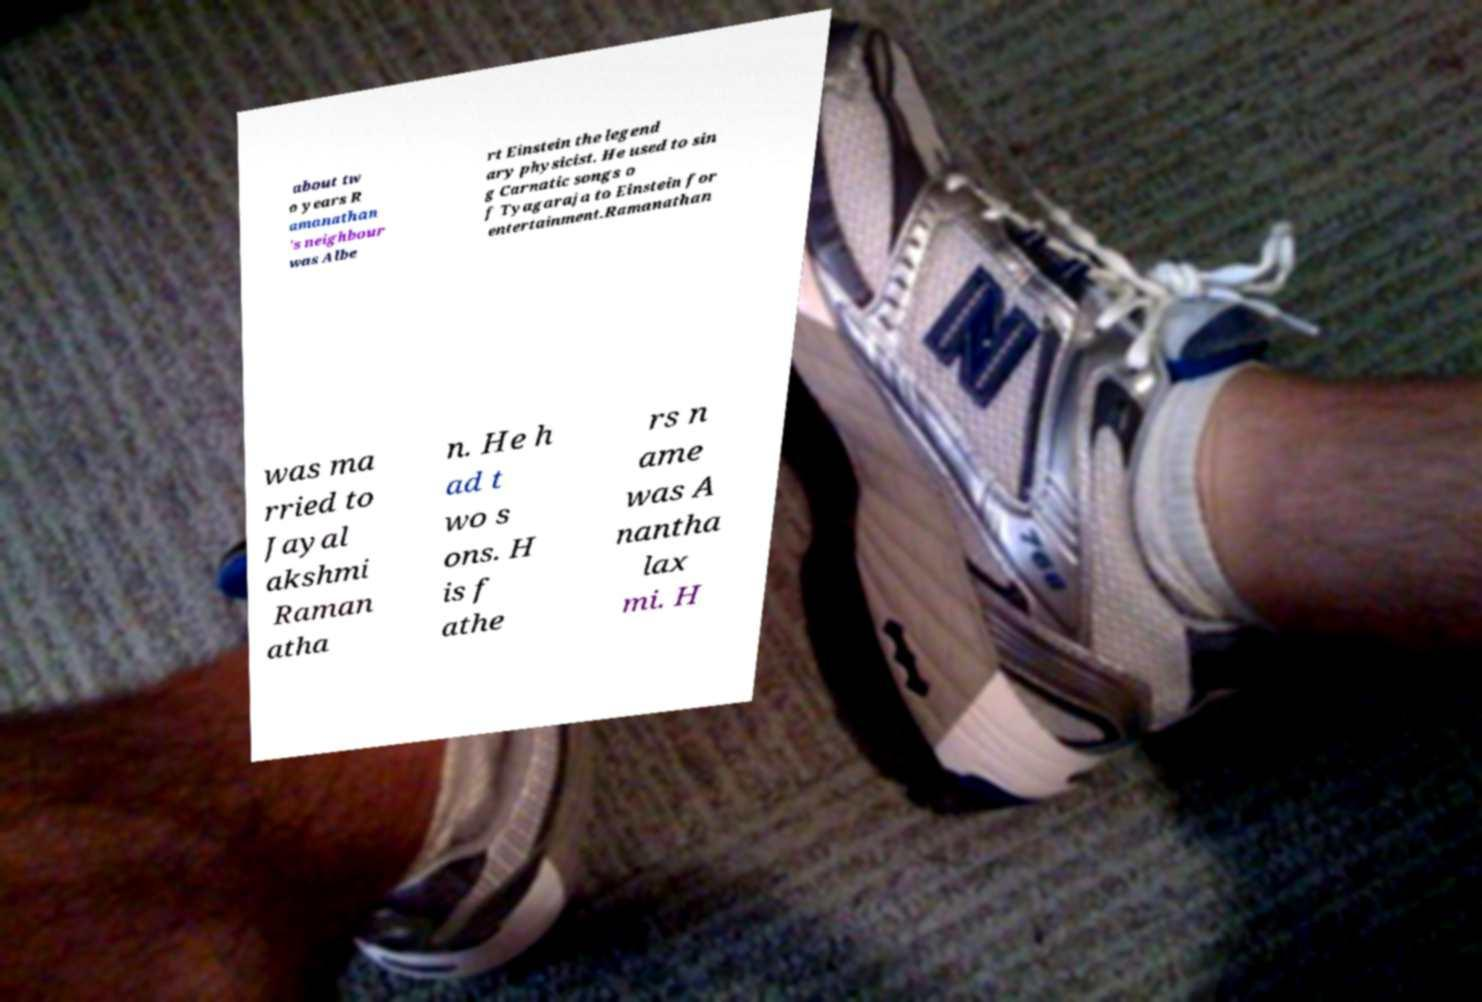Please read and relay the text visible in this image. What does it say? about tw o years R amanathan 's neighbour was Albe rt Einstein the legend ary physicist. He used to sin g Carnatic songs o f Tyagaraja to Einstein for entertainment.Ramanathan was ma rried to Jayal akshmi Raman atha n. He h ad t wo s ons. H is f athe rs n ame was A nantha lax mi. H 